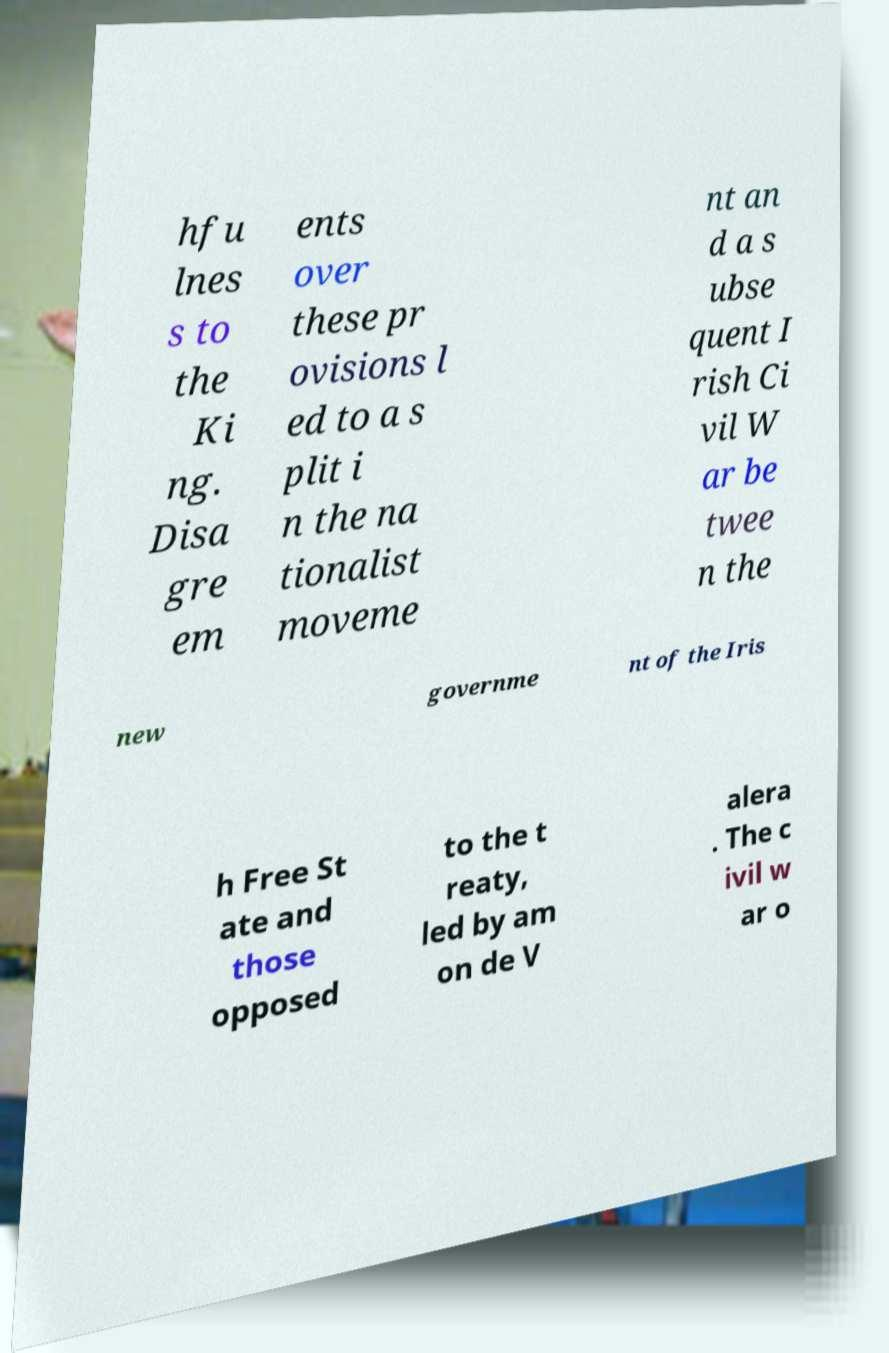For documentation purposes, I need the text within this image transcribed. Could you provide that? hfu lnes s to the Ki ng. Disa gre em ents over these pr ovisions l ed to a s plit i n the na tionalist moveme nt an d a s ubse quent I rish Ci vil W ar be twee n the new governme nt of the Iris h Free St ate and those opposed to the t reaty, led by am on de V alera . The c ivil w ar o 